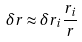<formula> <loc_0><loc_0><loc_500><loc_500>\delta r \approx \delta r _ { i } \frac { r _ { i } } { r }</formula> 